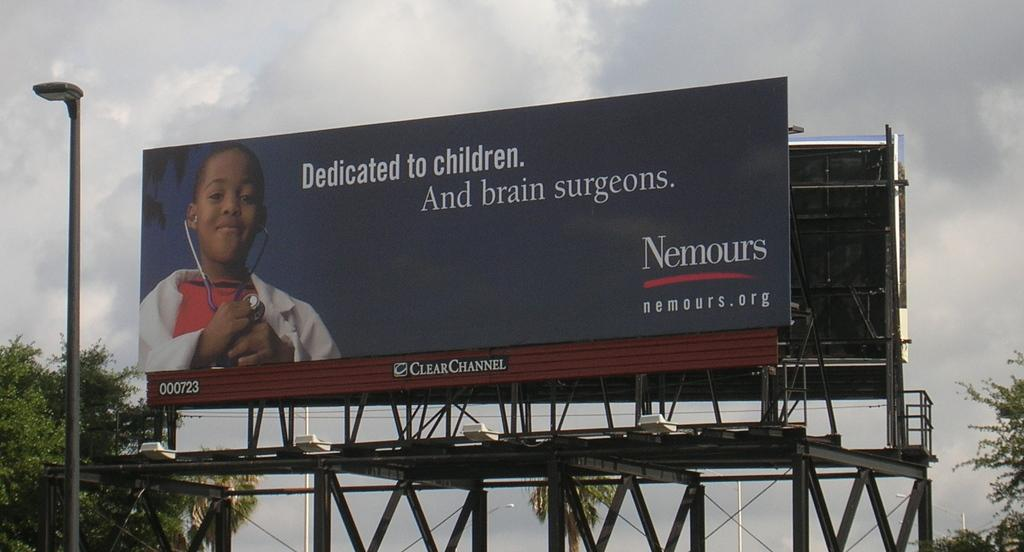Provide a one-sentence caption for the provided image. A billboard by Nemours shows a child dressed as a doctor. 